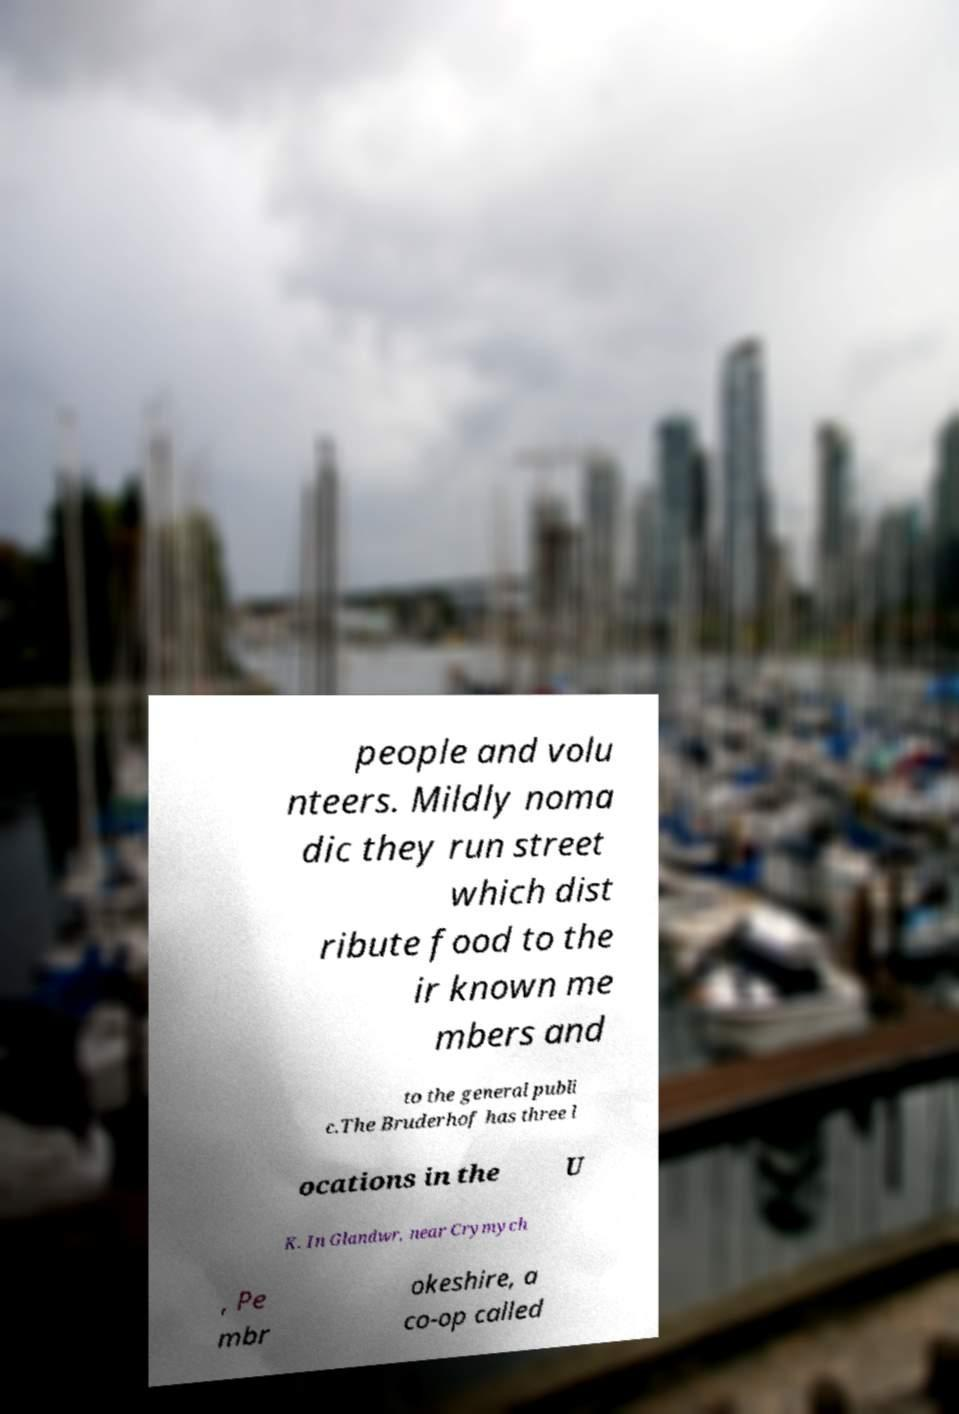Could you assist in decoding the text presented in this image and type it out clearly? people and volu nteers. Mildly noma dic they run street which dist ribute food to the ir known me mbers and to the general publi c.The Bruderhof has three l ocations in the U K. In Glandwr, near Crymych , Pe mbr okeshire, a co-op called 